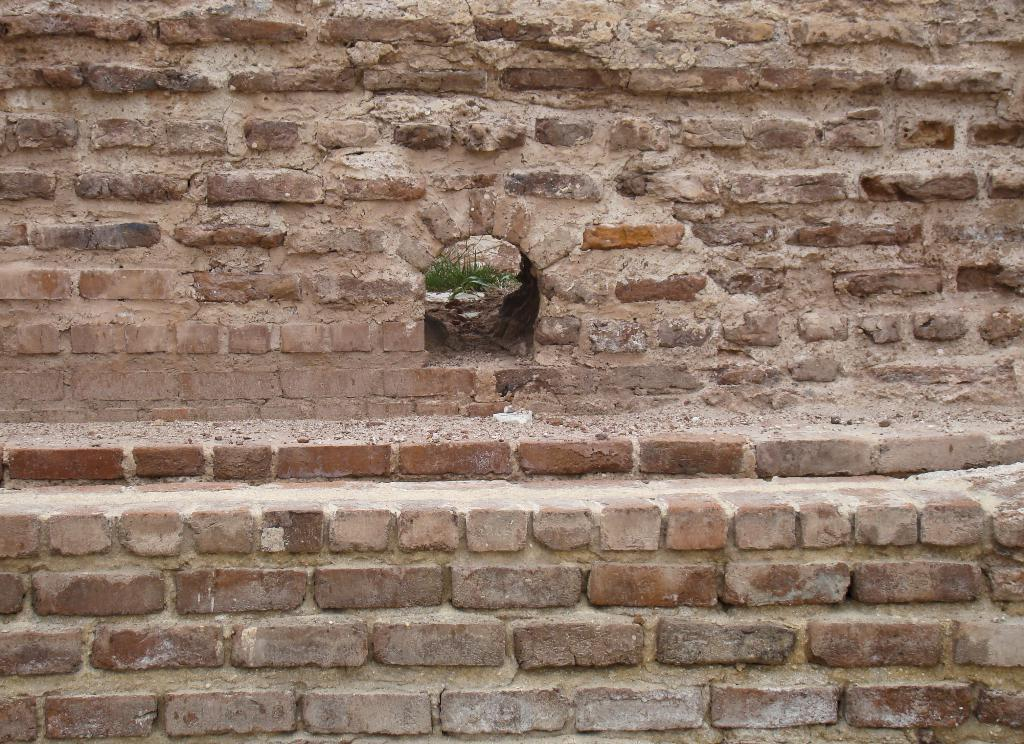What type of structure is visible in the image? There is a brick wall in the image. What feature can be seen in the brick wall? There is an arch-shaped hole in the brick wall. What is growing inside the hole in the brick wall? Grass is present inside the hole. How many tickets are visible in the image? There are no tickets present in the image. What type of utensil is used to crush the grass in the image? There is no utensil or action of crushing the grass in the image. 